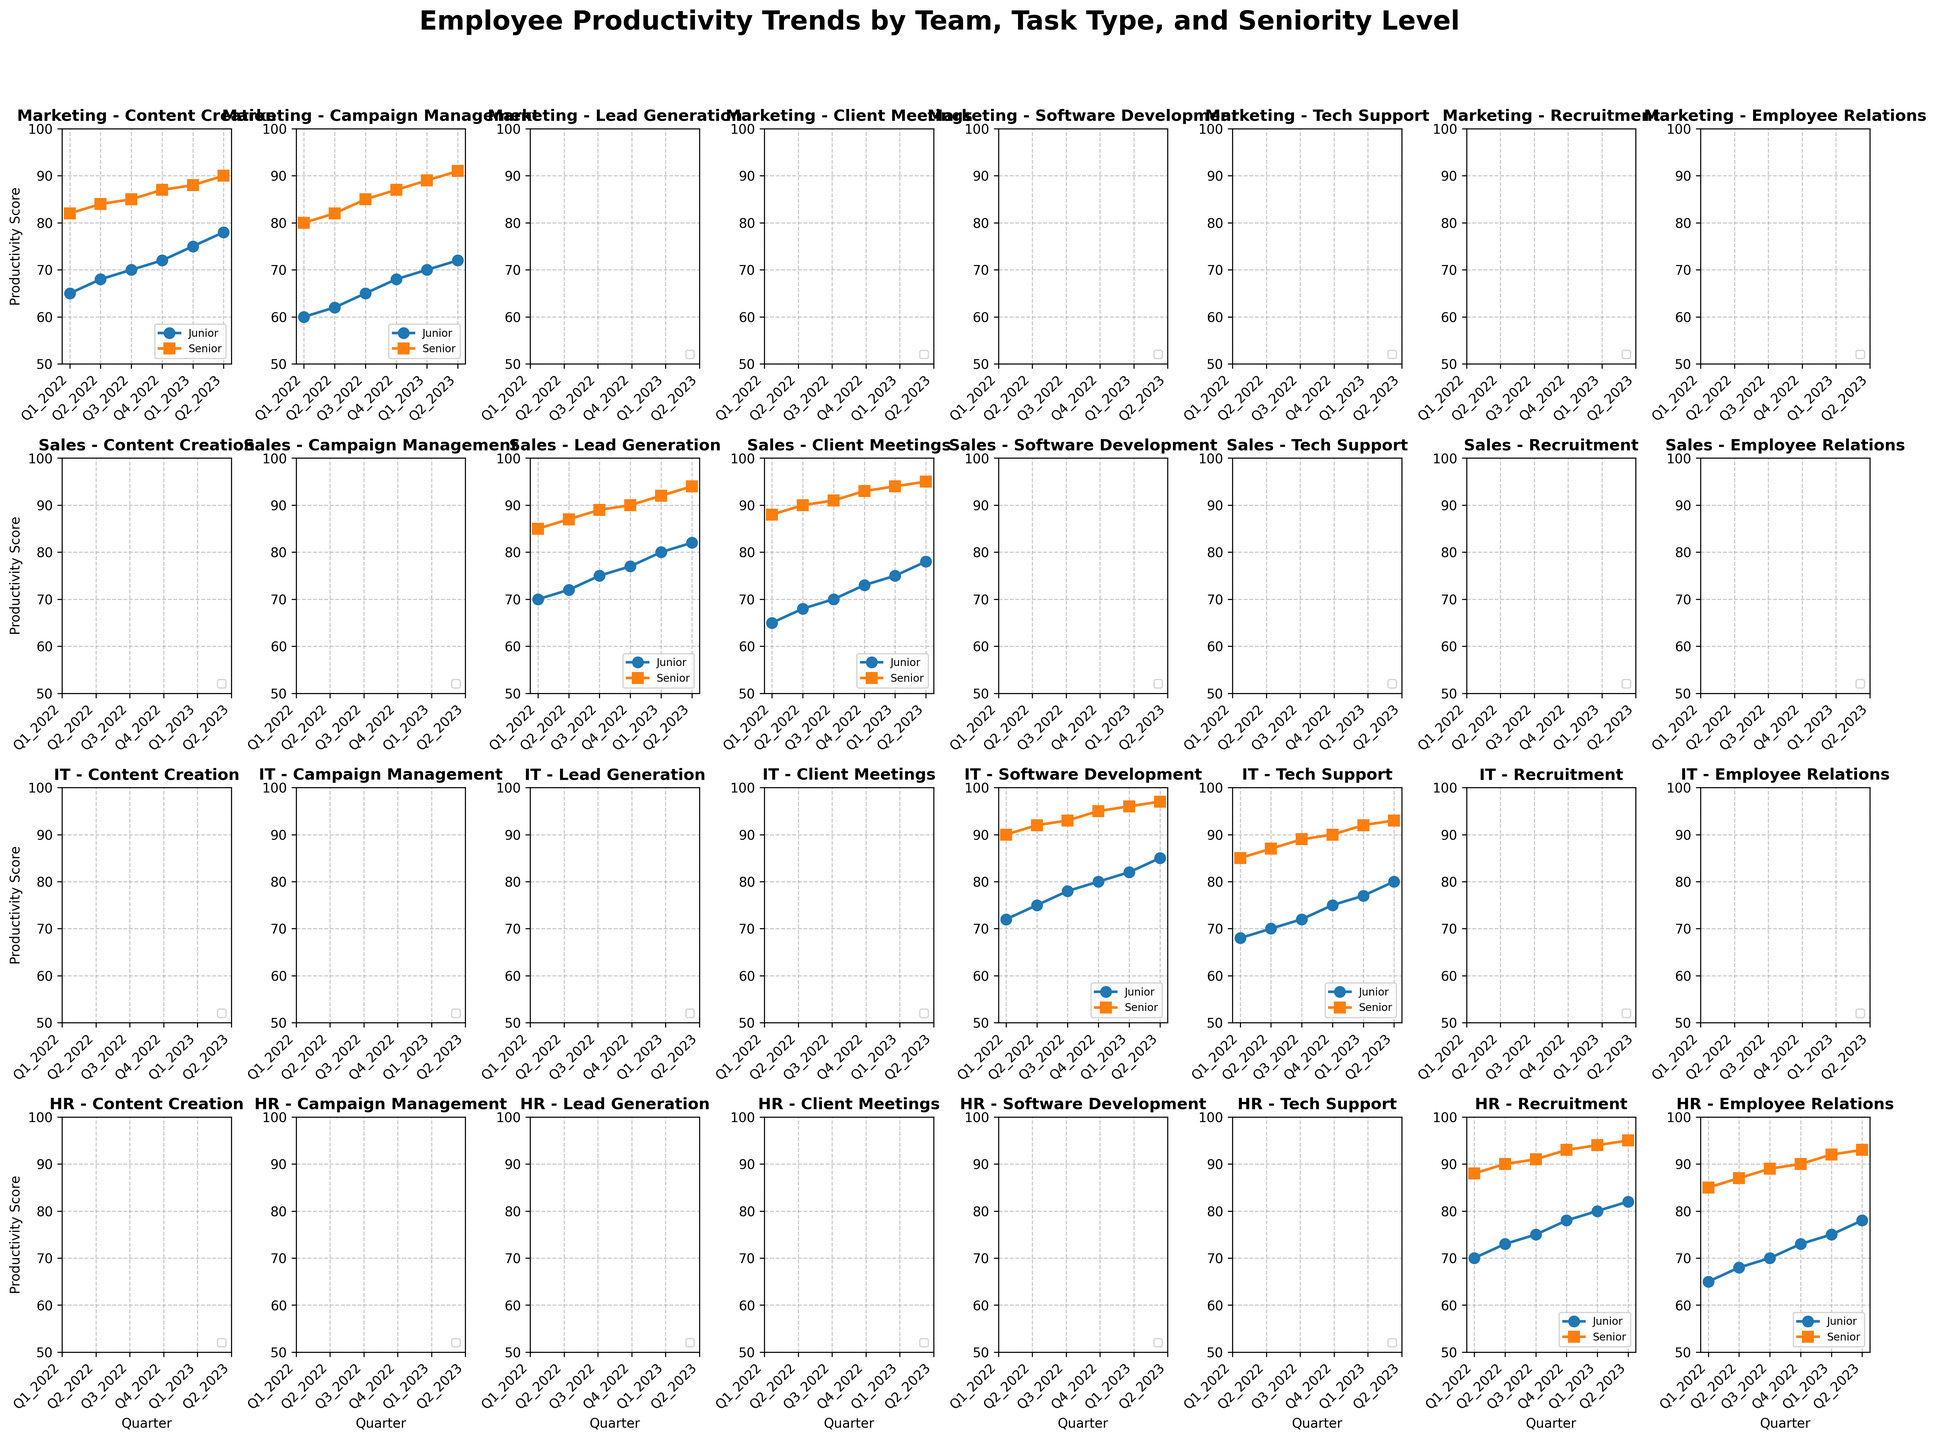Which team has the highest productivity score for juniors in Q2_2023? In Q2_2023, the productivity scores for juniors in each team are as follows: Marketing (Content Creation: 78, Campaign Management: 72), Sales (Lead Generation: 82, Client Meetings: 78), IT (Software Development: 85, Tech Support: 80), HR (Recruitment: 82, Employee Relations: 78). Sales’ Lead Generation juniors have the highest score of 82.
Answer: Sales How does the productivity trend differ between junior and senior employees in the Sales team for Client Meetings? For junior employees: productivity scores are 65, 68, 70, 73, 75, and 78 from Q1_2022 to Q2_2023. For senior employees: productivity scores are 88, 90, 91, 93, 94, 95 over the same period. Senior employees consistently have higher scores with a smaller increase over time compared to juniors.
Answer: Seniors show consistently higher scores with a smaller increase over time Which quarter shows the largest increase in productivity for juniors in the IT team for Software Development? The productivity scores for juniors in the IT team for Software Development are: Q1_2022 (72), Q2_2022 (75), Q3_2022 (78), Q4_2022 (80), Q1_2023 (82), Q2_2023 (85). The largest increase is from Q1_2022 to Q2_2022, with an increase of 3 points.
Answer: Q1_2022 to Q2_2022 What is the average productivity score for seniors in the Marketing team for Campaign Management over the quarters shown? The productivity scores for seniors in Campaign Management for Marketing are 80, 82, 85, 87, 89, and 91 from Q1_2022 to Q2_2023. Adding these scores gives 514. There are 6 data points, so the average is 514/6 = 85.67.
Answer: 85.67 Which team and task type combination shows the smallest difference in productivity scores between junior and senior employees in Q2_2023? The differences in productivity scores between juniors and seniors in Q2_2023 for each team and task type are: Marketing-Content Creation (78-90=12), Marketing-Campaign Management (72-91=19), Sales-Lead Generation (82-94=12), Sales-Client Meetings (78-95=17), IT-Software Development (85-97=12), IT-Tech Support (80-93=13), HR-Recruitment (82-95=13), HR-Employee Relations (78-93=15). The smallest differences are in Marketing-Content Creation, Sales-Lead Generation, and IT-Software Development (all 12 points).
Answer: Marketing-Content Creation, Sales-Lead Generation, and IT-Software Development How does the productivity trend for HR seniors in Recruitment compare to that in Employee Relations? For seniors in Recruitment: productivity scores are 88, 90, 91, 93, 94, 95 from Q1_2022 to Q2_2023. For seniors in Employee Relations: productivity scores are 85, 87, 89, 90, 92, 93. Recruitment shows a steady increase over time, whereas Employee Relations shows a smaller, slower increase.
Answer: Recruitment shows a steady increase, while Employee Relations has a slower, smaller increase 